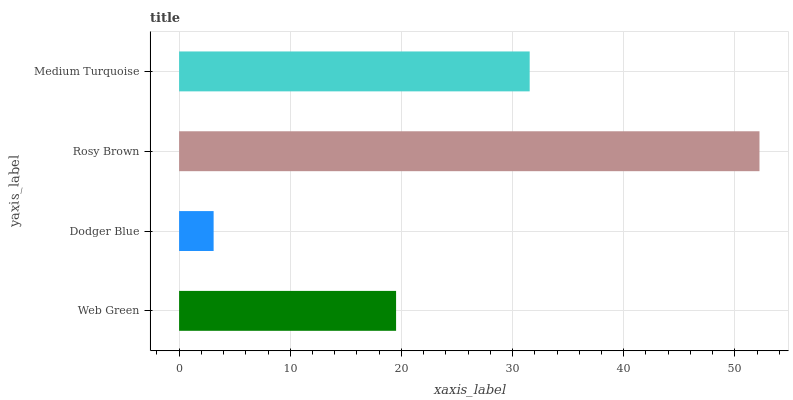Is Dodger Blue the minimum?
Answer yes or no. Yes. Is Rosy Brown the maximum?
Answer yes or no. Yes. Is Rosy Brown the minimum?
Answer yes or no. No. Is Dodger Blue the maximum?
Answer yes or no. No. Is Rosy Brown greater than Dodger Blue?
Answer yes or no. Yes. Is Dodger Blue less than Rosy Brown?
Answer yes or no. Yes. Is Dodger Blue greater than Rosy Brown?
Answer yes or no. No. Is Rosy Brown less than Dodger Blue?
Answer yes or no. No. Is Medium Turquoise the high median?
Answer yes or no. Yes. Is Web Green the low median?
Answer yes or no. Yes. Is Rosy Brown the high median?
Answer yes or no. No. Is Dodger Blue the low median?
Answer yes or no. No. 